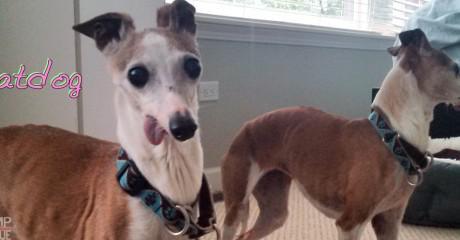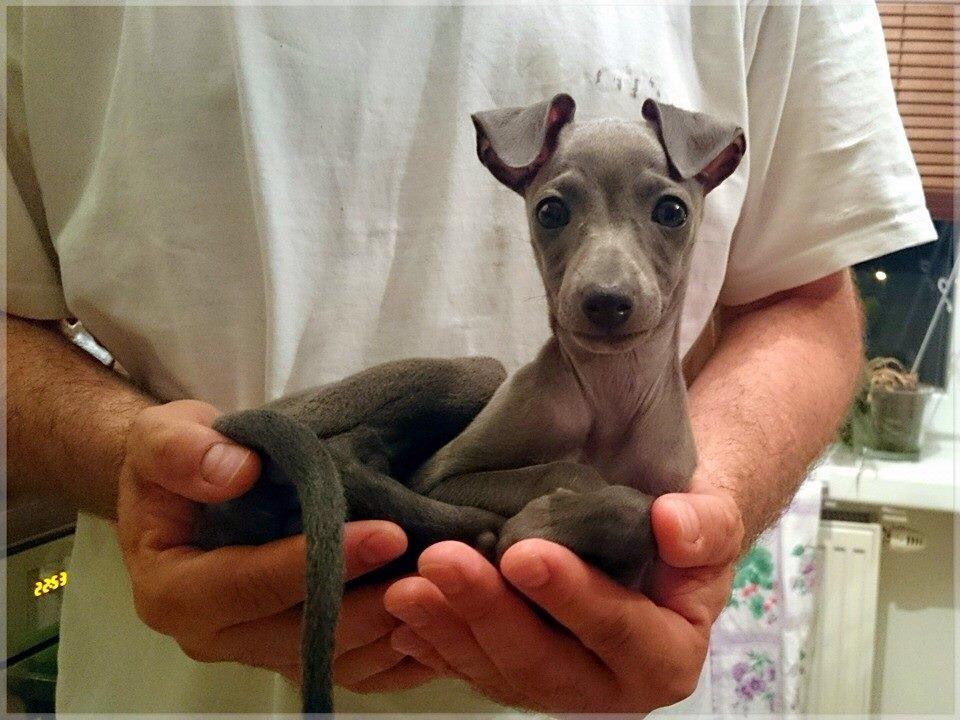The first image is the image on the left, the second image is the image on the right. Considering the images on both sides, is "there is an animal wrapped up in something blue in the image on the right side." valid? Answer yes or no. No. 